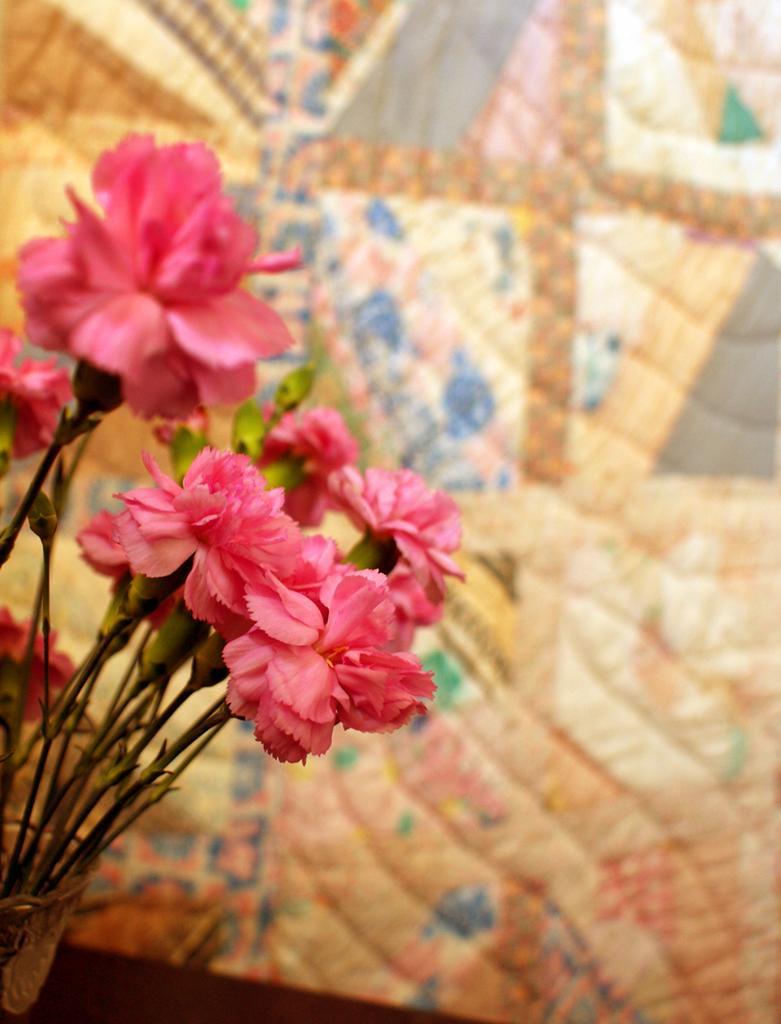In one or two sentences, can you explain what this image depicts? In the center of the image we can see flowers. In the background there is cloth. 